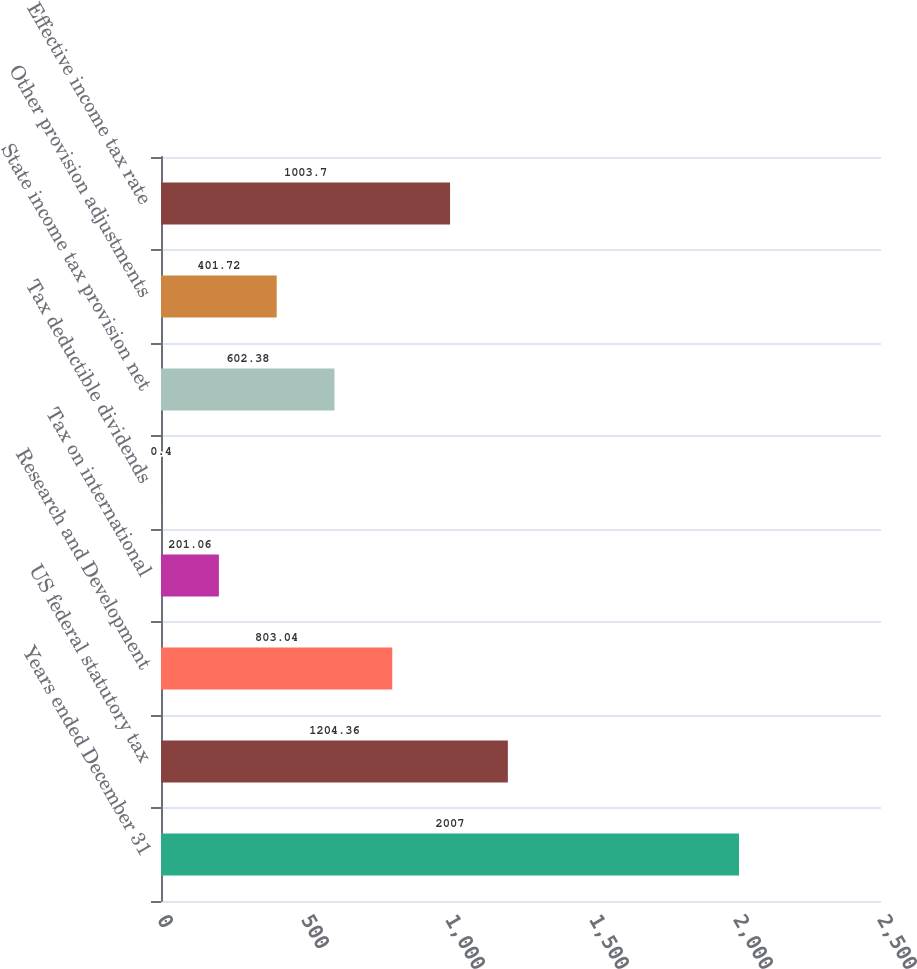Convert chart to OTSL. <chart><loc_0><loc_0><loc_500><loc_500><bar_chart><fcel>Years ended December 31<fcel>US federal statutory tax<fcel>Research and Development<fcel>Tax on international<fcel>Tax deductible dividends<fcel>State income tax provision net<fcel>Other provision adjustments<fcel>Effective income tax rate<nl><fcel>2007<fcel>1204.36<fcel>803.04<fcel>201.06<fcel>0.4<fcel>602.38<fcel>401.72<fcel>1003.7<nl></chart> 